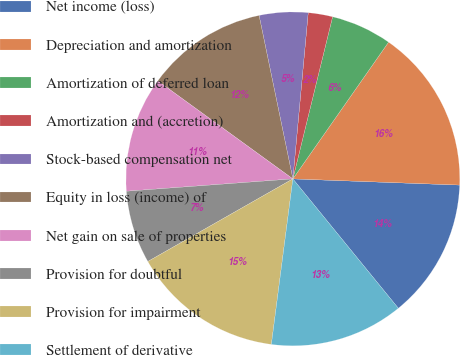Convert chart to OTSL. <chart><loc_0><loc_0><loc_500><loc_500><pie_chart><fcel>Net income (loss)<fcel>Depreciation and amortization<fcel>Amortization of deferred loan<fcel>Amortization and (accretion)<fcel>Stock-based compensation net<fcel>Equity in loss (income) of<fcel>Net gain on sale of properties<fcel>Provision for doubtful<fcel>Provision for impairment<fcel>Settlement of derivative<nl><fcel>13.52%<fcel>15.87%<fcel>5.89%<fcel>2.36%<fcel>4.71%<fcel>11.76%<fcel>11.17%<fcel>7.06%<fcel>14.7%<fcel>12.94%<nl></chart> 